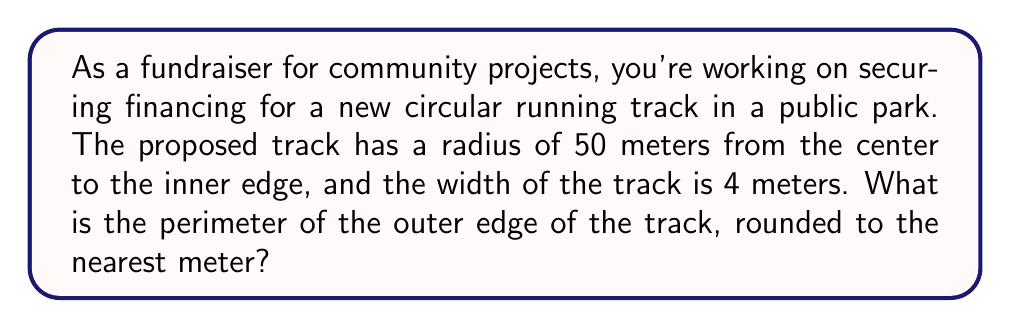Can you answer this question? To solve this problem, we need to follow these steps:

1. Understand the given information:
   - The inner radius of the track is 50 meters
   - The width of the track is 4 meters

2. Calculate the outer radius of the track:
   $$ r_{outer} = r_{inner} + width $$
   $$ r_{outer} = 50 m + 4 m = 54 m $$

3. Use the formula for the circumference of a circle to calculate the perimeter:
   $$ C = 2\pi r $$
   Where:
   $C$ is the circumference (perimeter)
   $\pi$ is approximately 3.14159
   $r$ is the radius

4. Plug in the outer radius:
   $$ C = 2\pi(54) $$
   $$ C = 108\pi $$

5. Calculate the result:
   $$ C \approx 108 \times 3.14159 \approx 339.29 \text{ meters} $$

6. Round to the nearest meter:
   $$ C \approx 339 \text{ meters} $$

[asy]
import geometry;

size(200);
pair center = (0,0);
real inner_radius = 5;
real outer_radius = 5.4;

draw(circle(center, inner_radius), gray);
draw(circle(center, outer_radius), blue+1);

label("50m", (inner_radius/2,0), E);
label("4m", (inner_radius+0.2,0), N);
label("54m", (outer_radius/2,0), SE);

draw((inner_radius,0)--(outer_radius,0), arrow=Arrow(TeXHead));
[/asy]

This diagram illustrates the cross-section of the track, showing the inner and outer radii.
Answer: The perimeter of the outer edge of the proposed circular running track is approximately 339 meters. 